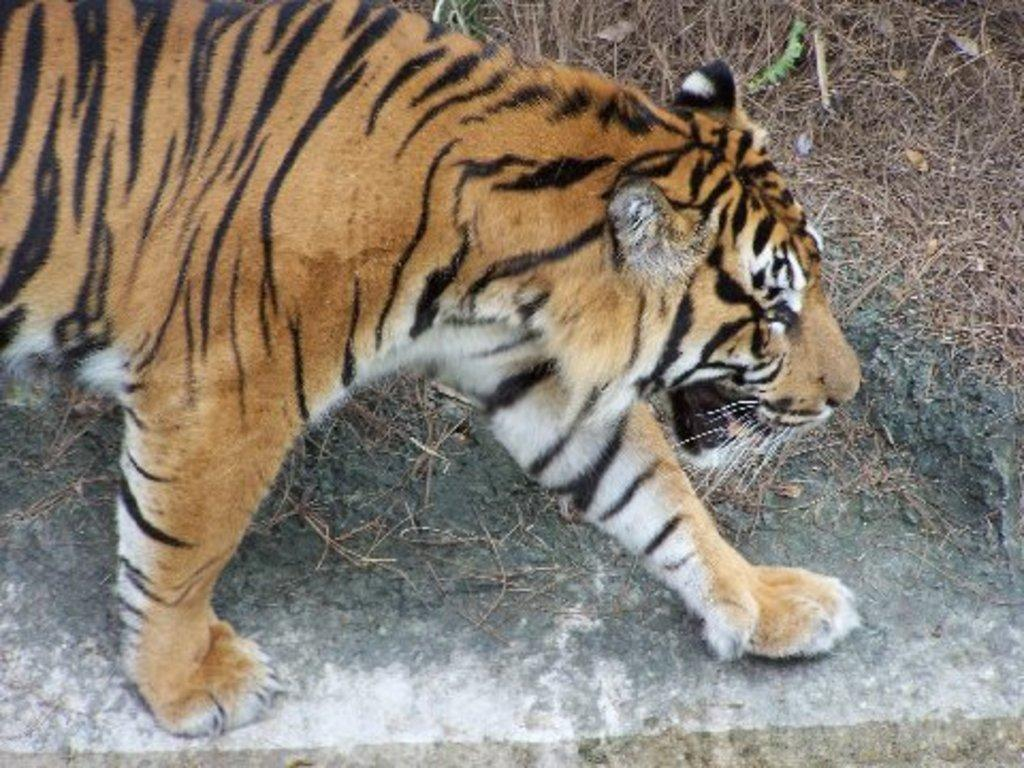What animal is present in the image? There is a tiger in the image. Where is the tiger located? The tiger is on the ground. What can be seen on the ground besides the tiger? There are dry stems on the ground. What type of building can be seen in the background of the image? There is no building present in the image; it only features a tiger on the ground and dry stems. 